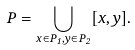Convert formula to latex. <formula><loc_0><loc_0><loc_500><loc_500>P = \bigcup _ { x \in P _ { 1 } , y \in P _ { 2 } } [ x , y ] .</formula> 